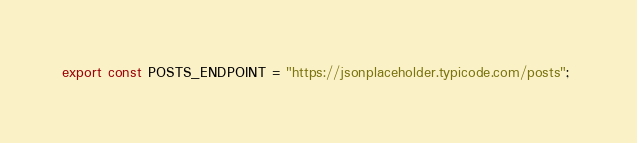<code> <loc_0><loc_0><loc_500><loc_500><_JavaScript_>export const POSTS_ENDPOINT = "https://jsonplaceholder.typicode.com/posts"; </code> 